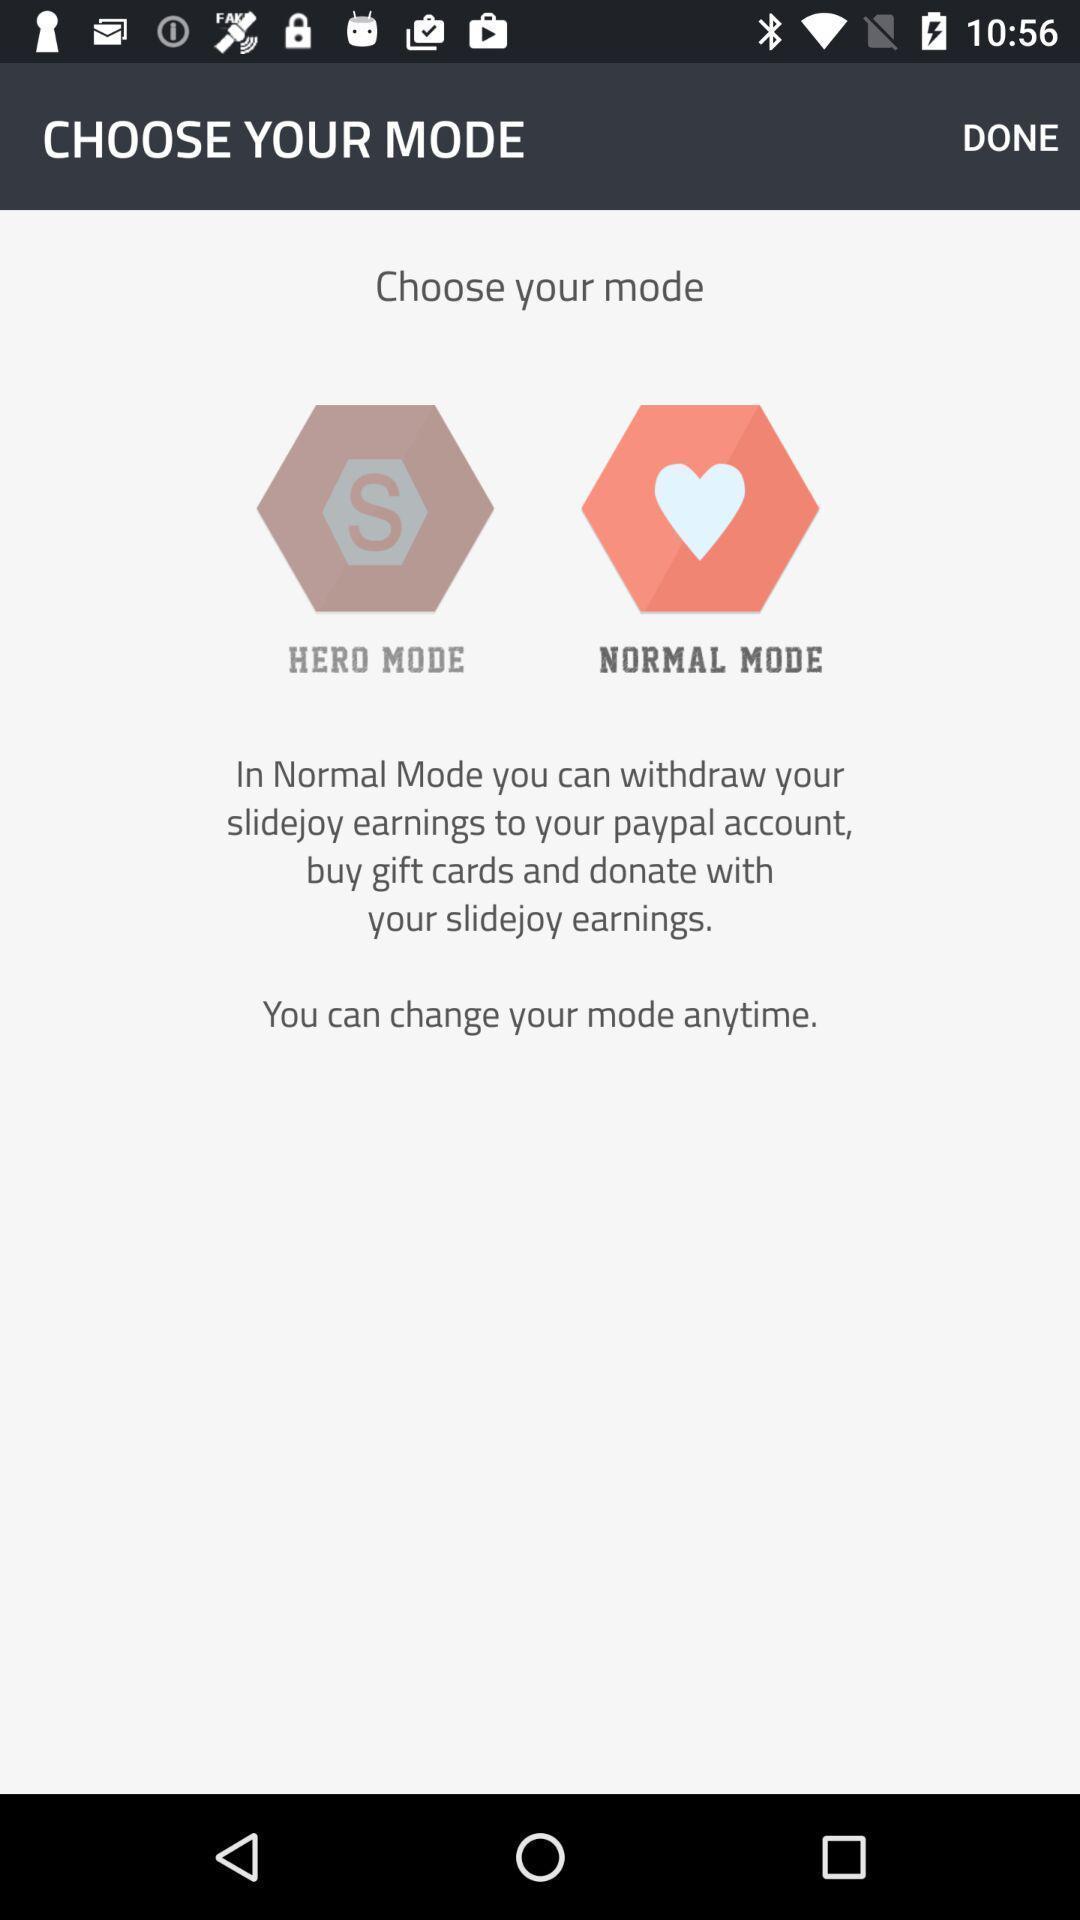Summarize the main components in this picture. Page displaying to choose mode in app. 